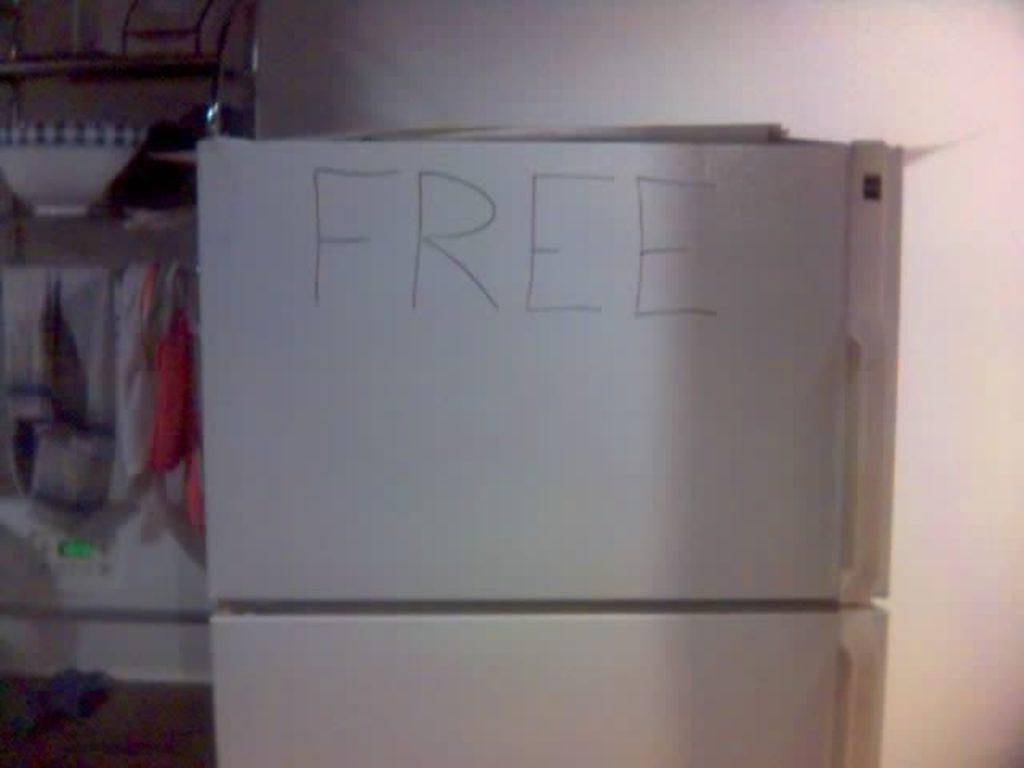What is the color of the box that is visible in the image? The box in the image is white. How is the white color box positioned in the image? The white color box is placed on another white color box. What can be seen on the wall in the background of the image? There is a poster on the wall in the background of the image. What type of paint is being used by the pet in the image? There is no pet or paint present in the image. How does the bubble affect the white color box in the image? There is no bubble present in the image, so it cannot affect the white color box. 